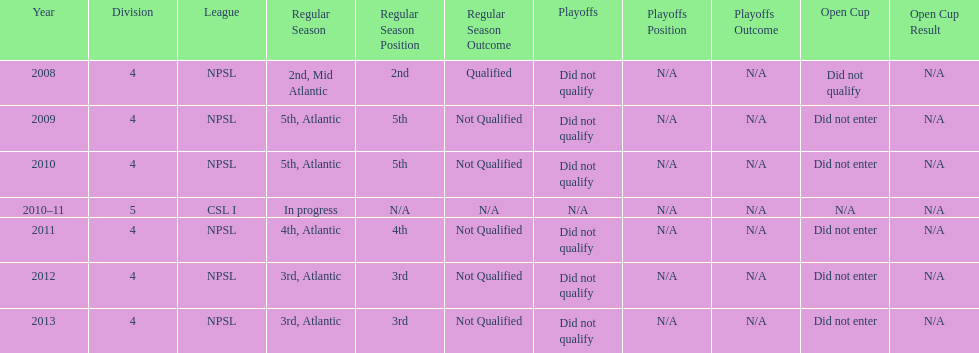Using the data, what should be the next year they will play? 2014. 